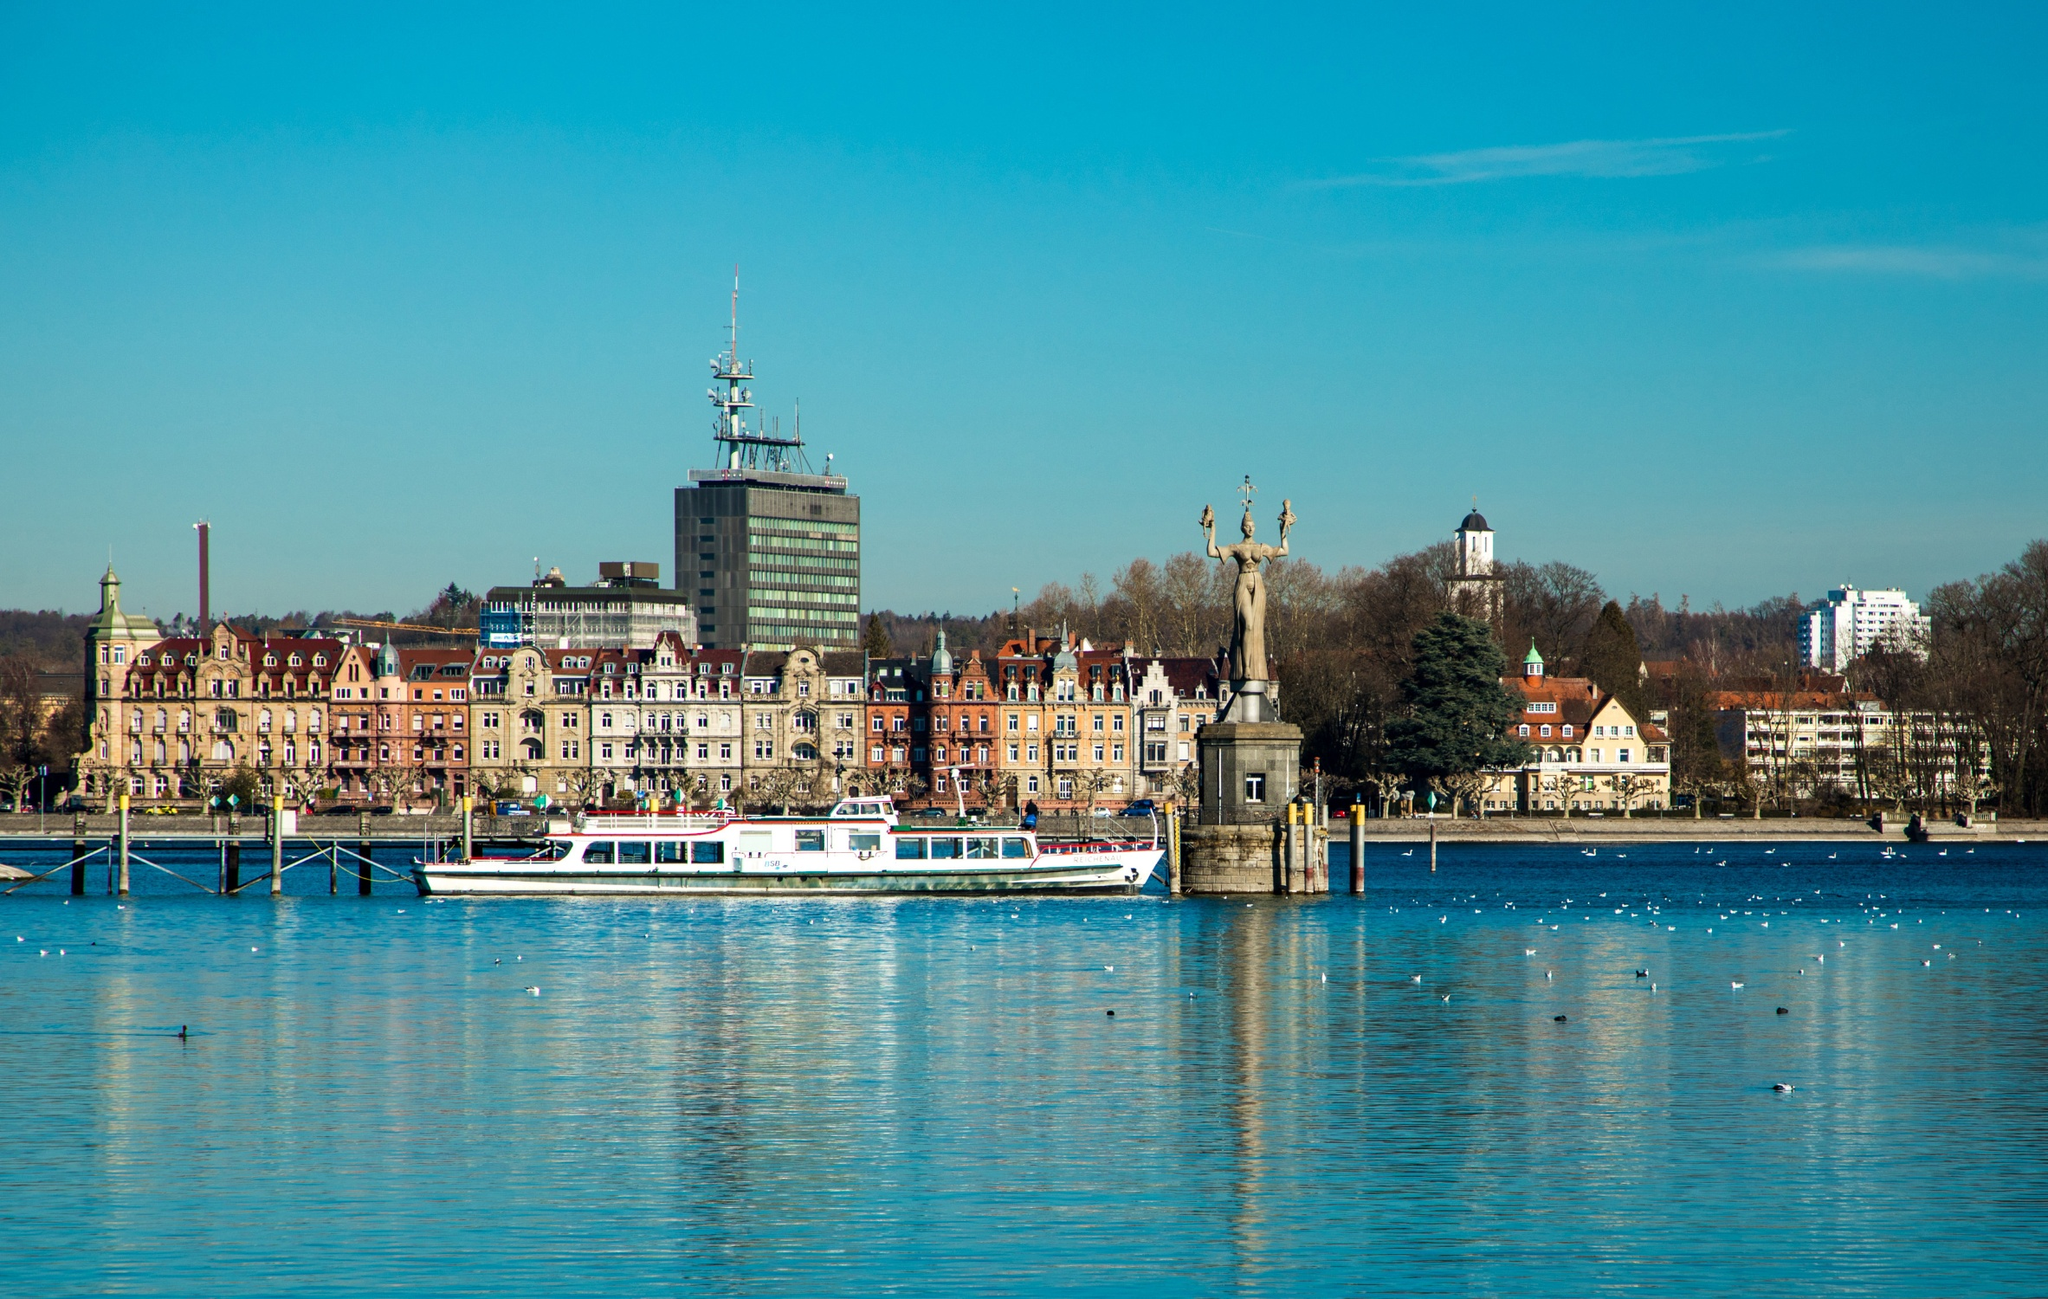Describe a peaceful day in Constance Harbour, including the activities people might engage in. On a peaceful day in Constance Harbour, the tranquil waters mirror the clear skies above, creating a serene and picturesque environment. Early risers begin their day by taking a leisurely stroll along the promenade, enjoying the crisp morning air and the melodic calls of seabirds. Families gather near the historic landmarks, picnicking on grassy knolls and taking in the sights of colorful houses and majestic statues. Boats dock quietly at the piers, with tourists steadily boarding for a relaxing tour around the lake, captivated by the stunning views and historic tales from the guides. Artists set up their canvases, inspired by the breathtaking scenery, while fishermen cast lines, hoping for a good haul. Street musicians add a melodic charm, filling the air with soft tunes that blend seamlessly with the sounds of the harbor. Children play by the water’s edge, their laughter ringing out as they skip stones and chase one another. As the day progresses, cafes and restaurants overlooking the harbor fill with patrons sipping on coffee, enjoying fine dining, and engaging in lighthearted conversations. The peaceful atmosphere of Constance Harbour creates a perfect setting for relaxation and enjoyment, leaving an indelible mark on all who visit.  Fill in details for a postcard describing a visit to Constance Harbour. Dear Friend,\nToday, I visited the breathtaking Constance Harbour in Germany. The serene blend of blue skies and waters was simply mesmerizing. A stroll along the promenade offered captivating views of charming old buildings mingling perfectly with modern structures, and the historic Imperia statue added a touch of timeless beauty. I enjoyed a delightful boat ride across the calm waters and savored delicious local cuisine at a picturesque cafe overlooking the harbour. This place is a harmonious haven of nature, history, and modernity—truly a sight to behold!\nWish you were here,\n[Your Name] 